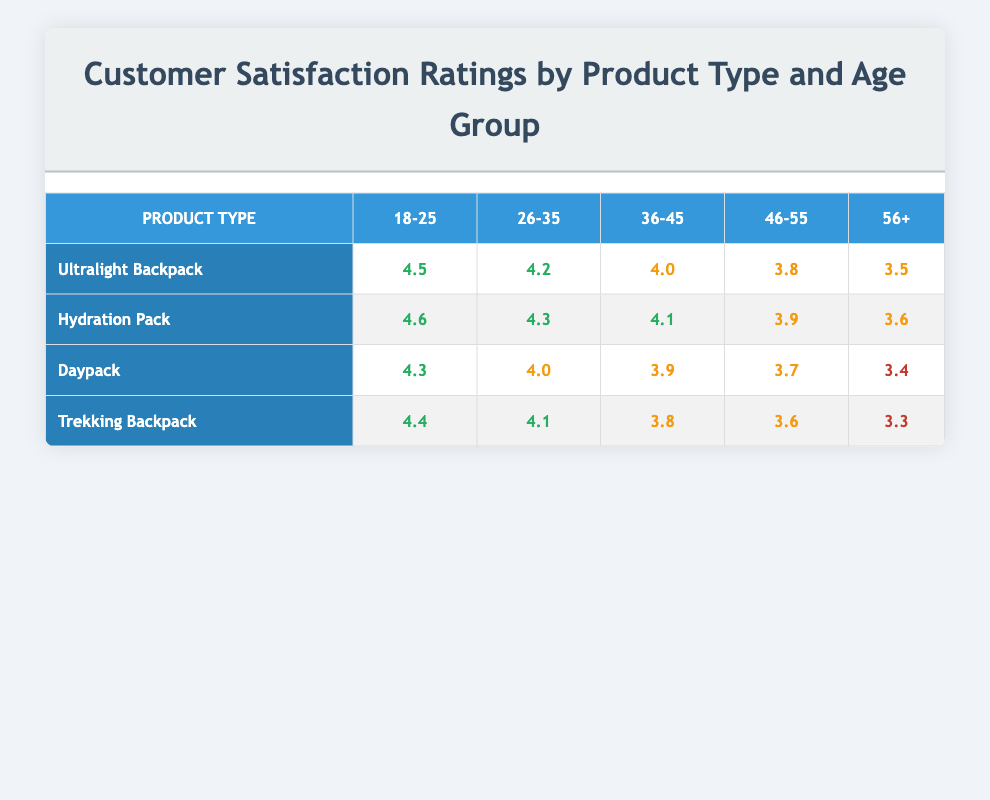What is the satisfaction rating for the Ultralight Backpack in the age group 36-45? The table shows that the satisfaction rating for the Ultralight Backpack in the age group 36-45 is 4.0.
Answer: 4.0 Which product has the highest satisfaction rating among 18-25 year-olds? By comparing the ratings in the 18-25 column, the Hydration Pack has the highest rating at 4.6, more than Ultralight Backpack at 4.5 and others.
Answer: Hydration Pack What is the average satisfaction rating for the Daypack across all age groups? The ratings for Daypack are 4.3, 4.0, 3.9, 3.7, and 3.4. Summing these gives 4.3 + 4.0 + 3.9 + 3.7 + 3.4 = 19.3. Dividing by 5 gives an average of 19.3 / 5 = 3.86.
Answer: 3.86 Is the satisfaction rating for the Trekking Backpack higher than that of the Hydration Pack for the age group 46-55? For the age group 46-55, the Trekking Backpack has a rating of 3.6 while the Hydration Pack has a rating of 3.9, meaning the Trekking Backpack’s rating is lower.
Answer: No What is the difference in satisfaction ratings between the Hydration Pack and the Ultralight Backpack for the age group 26-35? The satisfaction rating for the Hydration Pack in this age group is 4.3, while for the Ultralight Backpack it is 4.2. The difference is 4.3 - 4.2 = 0.1.
Answer: 0.1 Which age group shows the lowest satisfaction rating for the Daypack? The table lists the ratings for the Daypack across age groups, and the lowest rating is 3.4 for the age group 56+.
Answer: 56+ What are the two lowest satisfaction ratings for product types, and which age group do they correspond to? Examining the table, the two lowest ratings are 3.3 (Trekking Backpack, 56+) and 3.4 (Daypack, 56+).
Answer: 3.3 (Trekking Backpack, 56+), 3.4 (Daypack, 56+) Is the average satisfaction rating for the Ultralight Backpack lower than that of the Hydration Pack? For the Ultralight Backpack, the ratings are 4.5, 4.2, 4.0, 3.8, and 3.5, which sums to 20.0, giving an average of 20.0 / 5 = 4.0. For the Hydration Pack, ratings are 4.6, 4.3, 4.1, 3.9, and 3.6, summing up to 20.5 giving an average of 20.5 / 5 = 4.1. Since 4.0 < 4.1, the statement is true.
Answer: Yes What is the satisfaction rating for the Hydration Pack in the age group 46-55 compared to that of the Trekking Backpack in the same age group? The Hydration Pack has a rating of 3.9 for age group 46-55 while the Trekking Backpack has a rating of 3.6, indicating the Hydration Pack’s rating is higher.
Answer: Hydration Pack is higher 